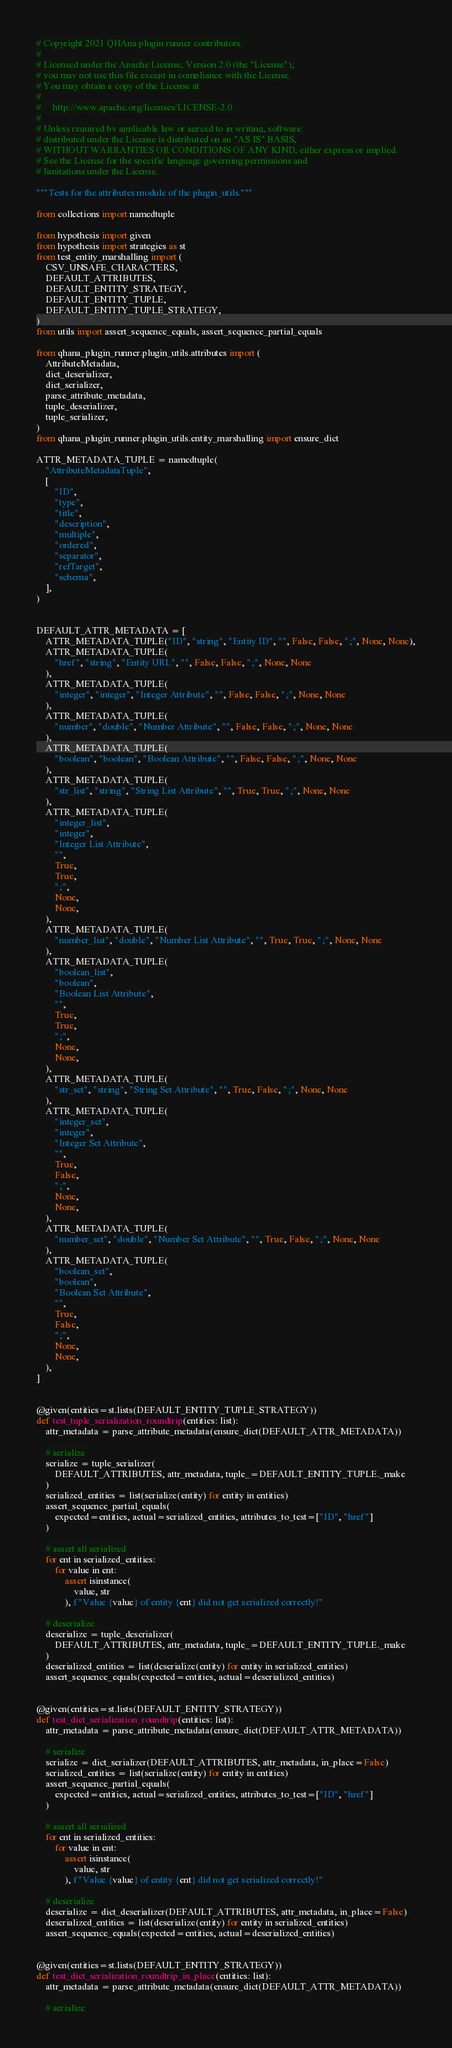Convert code to text. <code><loc_0><loc_0><loc_500><loc_500><_Python_># Copyright 2021 QHAna plugin runner contributors.
#
# Licensed under the Apache License, Version 2.0 (the "License");
# you may not use this file except in compliance with the License.
# You may obtain a copy of the License at
#
#     http://www.apache.org/licenses/LICENSE-2.0
#
# Unless required by applicable law or agreed to in writing, software
# distributed under the License is distributed on an "AS IS" BASIS,
# WITHOUT WARRANTIES OR CONDITIONS OF ANY KIND, either express or implied.
# See the License for the specific language governing permissions and
# limitations under the License.

"""Tests for the attributes module of the plugin_utils."""

from collections import namedtuple

from hypothesis import given
from hypothesis import strategies as st
from test_entity_marshalling import (
    CSV_UNSAFE_CHARACTERS,
    DEFAULT_ATTRIBUTES,
    DEFAULT_ENTITY_STRATEGY,
    DEFAULT_ENTITY_TUPLE,
    DEFAULT_ENTITY_TUPLE_STRATEGY,
)
from utils import assert_sequence_equals, assert_sequence_partial_equals

from qhana_plugin_runner.plugin_utils.attributes import (
    AttributeMetadata,
    dict_deserializer,
    dict_serializer,
    parse_attribute_metadata,
    tuple_deserializer,
    tuple_serializer,
)
from qhana_plugin_runner.plugin_utils.entity_marshalling import ensure_dict

ATTR_METADATA_TUPLE = namedtuple(
    "AttributeMetadataTuple",
    [
        "ID",
        "type",
        "title",
        "description",
        "multiple",
        "ordered",
        "separator",
        "refTarget",
        "schema",
    ],
)


DEFAULT_ATTR_METADATA = [
    ATTR_METADATA_TUPLE("ID", "string", "Entity ID", "", False, False, ";", None, None),
    ATTR_METADATA_TUPLE(
        "href", "string", "Entity URL", "", False, False, ";", None, None
    ),
    ATTR_METADATA_TUPLE(
        "integer", "integer", "Integer Attribute", "", False, False, ";", None, None
    ),
    ATTR_METADATA_TUPLE(
        "number", "double", "Number Attribute", "", False, False, ";", None, None
    ),
    ATTR_METADATA_TUPLE(
        "boolean", "boolean", "Boolean Attribute", "", False, False, ";", None, None
    ),
    ATTR_METADATA_TUPLE(
        "str_list", "string", "String List Attribute", "", True, True, ";", None, None
    ),
    ATTR_METADATA_TUPLE(
        "integer_list",
        "integer",
        "Integer List Attribute",
        "",
        True,
        True,
        ";",
        None,
        None,
    ),
    ATTR_METADATA_TUPLE(
        "number_list", "double", "Number List Attribute", "", True, True, ";", None, None
    ),
    ATTR_METADATA_TUPLE(
        "boolean_list",
        "boolean",
        "Boolean List Attribute",
        "",
        True,
        True,
        ";",
        None,
        None,
    ),
    ATTR_METADATA_TUPLE(
        "str_set", "string", "String Set Attribute", "", True, False, ";", None, None
    ),
    ATTR_METADATA_TUPLE(
        "integer_set",
        "integer",
        "Integer Set Attribute",
        "",
        True,
        False,
        ";",
        None,
        None,
    ),
    ATTR_METADATA_TUPLE(
        "number_set", "double", "Number Set Attribute", "", True, False, ";", None, None
    ),
    ATTR_METADATA_TUPLE(
        "boolean_set",
        "boolean",
        "Boolean Set Attribute",
        "",
        True,
        False,
        ";",
        None,
        None,
    ),
]


@given(entities=st.lists(DEFAULT_ENTITY_TUPLE_STRATEGY))
def test_tuple_serialization_roundtrip(entities: list):
    attr_metadata = parse_attribute_metadata(ensure_dict(DEFAULT_ATTR_METADATA))

    # serialize
    serialize = tuple_serializer(
        DEFAULT_ATTRIBUTES, attr_metadata, tuple_=DEFAULT_ENTITY_TUPLE._make
    )
    serialized_entities = list(serialize(entity) for entity in entities)
    assert_sequence_partial_equals(
        expected=entities, actual=serialized_entities, attributes_to_test=["ID", "href"]
    )

    # assert all serialized
    for ent in serialized_entities:
        for value in ent:
            assert isinstance(
                value, str
            ), f"Value {value} of entity {ent} did not get serialized correctly!"

    # deserialize
    deserialize = tuple_deserializer(
        DEFAULT_ATTRIBUTES, attr_metadata, tuple_=DEFAULT_ENTITY_TUPLE._make
    )
    deserialized_entities = list(deserialize(entity) for entity in serialized_entities)
    assert_sequence_equals(expected=entities, actual=deserialized_entities)


@given(entities=st.lists(DEFAULT_ENTITY_STRATEGY))
def test_dict_serialization_roundtrip(entities: list):
    attr_metadata = parse_attribute_metadata(ensure_dict(DEFAULT_ATTR_METADATA))

    # serialize
    serialize = dict_serializer(DEFAULT_ATTRIBUTES, attr_metadata, in_place=False)
    serialized_entities = list(serialize(entity) for entity in entities)
    assert_sequence_partial_equals(
        expected=entities, actual=serialized_entities, attributes_to_test=["ID", "href"]
    )

    # assert all serialized
    for ent in serialized_entities:
        for value in ent:
            assert isinstance(
                value, str
            ), f"Value {value} of entity {ent} did not get serialized correctly!"

    # deserialize
    deserialize = dict_deserializer(DEFAULT_ATTRIBUTES, attr_metadata, in_place=False)
    deserialized_entities = list(deserialize(entity) for entity in serialized_entities)
    assert_sequence_equals(expected=entities, actual=deserialized_entities)


@given(entities=st.lists(DEFAULT_ENTITY_STRATEGY))
def test_dict_serialization_roundtrip_in_place(entities: list):
    attr_metadata = parse_attribute_metadata(ensure_dict(DEFAULT_ATTR_METADATA))

    # serialize</code> 